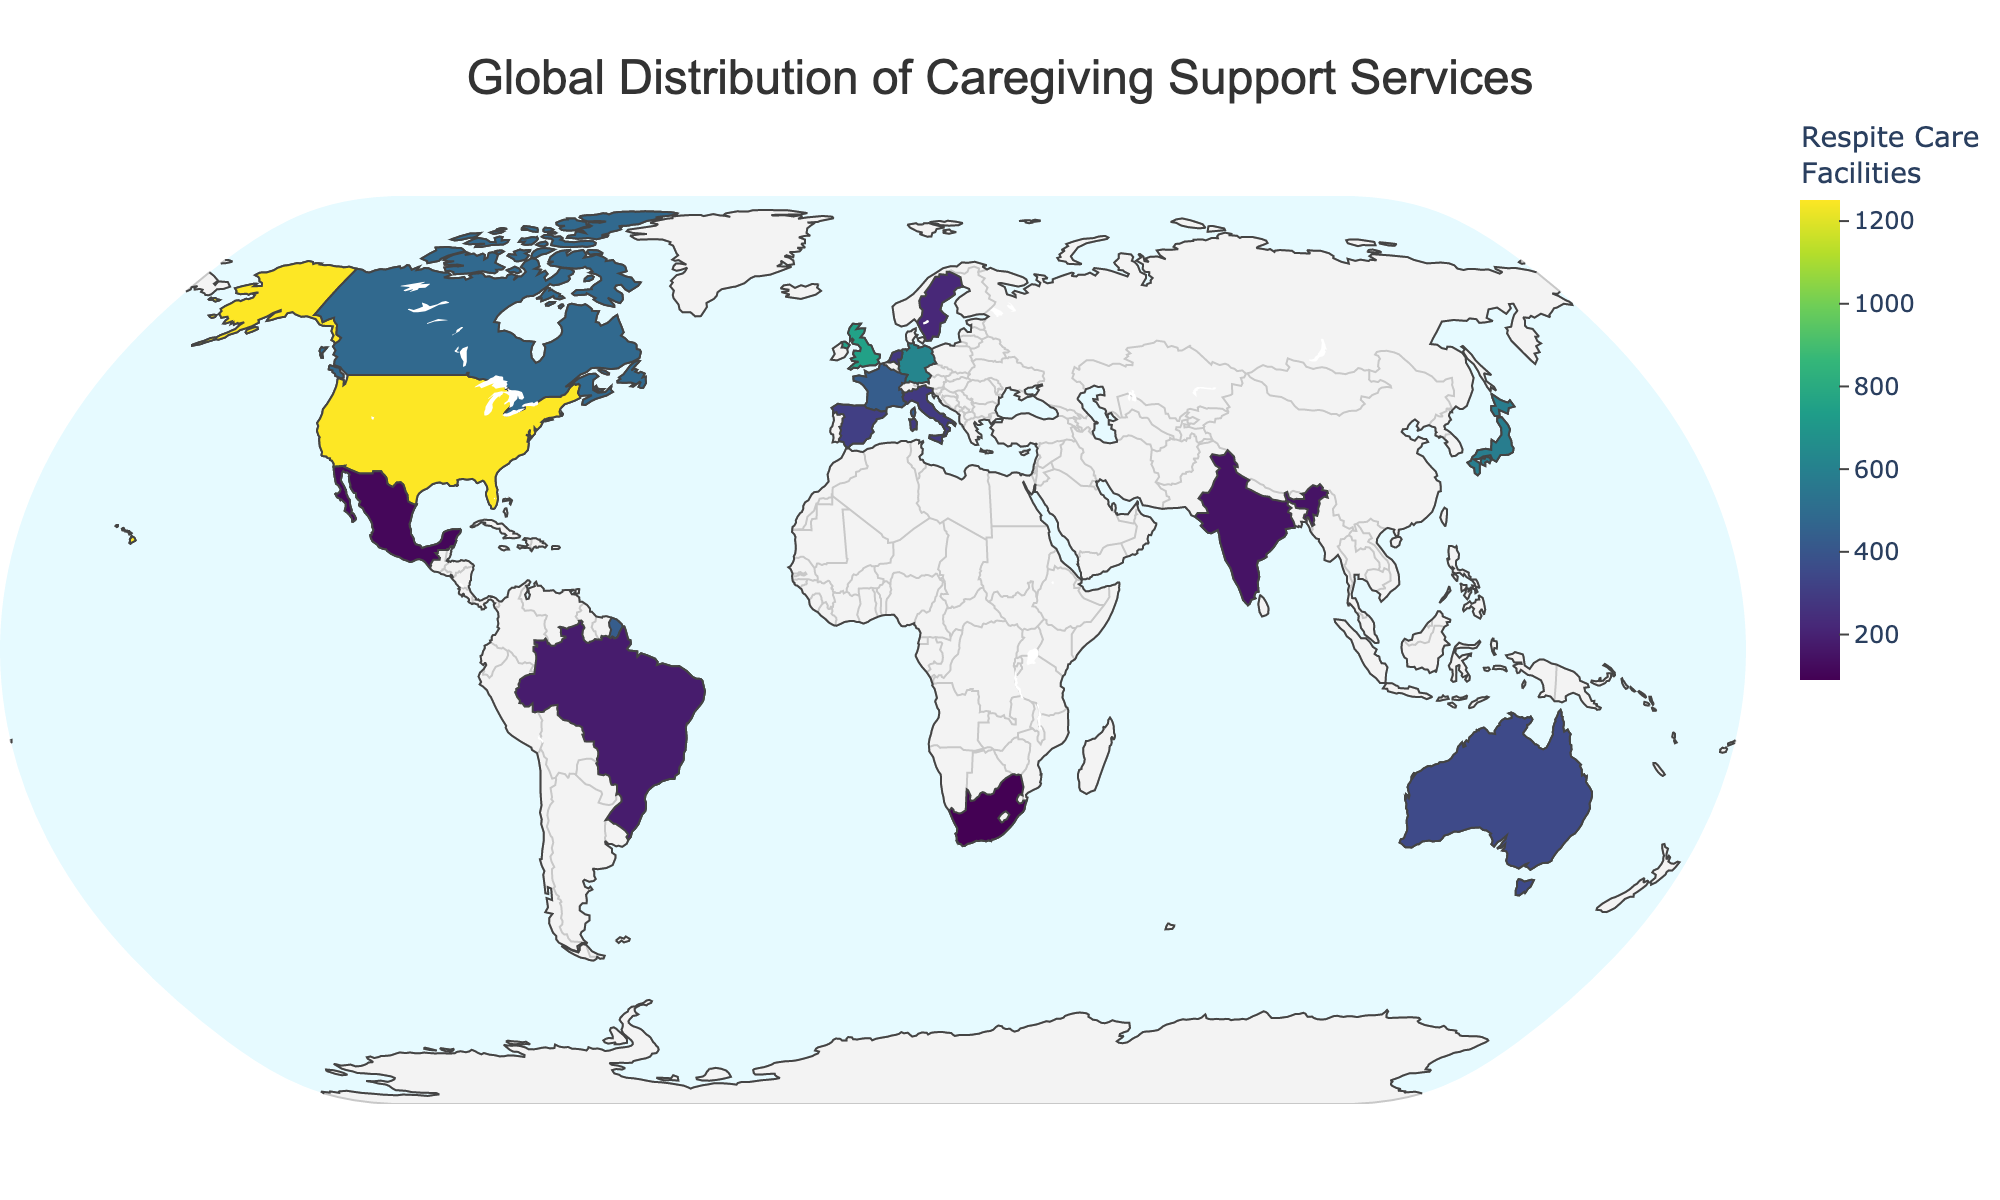What's the country with the highest number of respite care facilities? To find the country with the highest number of respite care facilities, look for the country with the darkest shade on the color scale or check the data for the highest value in the "Respite Care Facilities" column. The United States has the highest number with 1250 facilities.
Answer: United States Which regions have relatively fewer respite care facilities? Identify the countries with lighter shades on the color scale. The countries with relatively fewer facilities are South Africa, Mexico, India, and Brazil.
Answer: South Africa, Mexico, India, Brazil How many respite care facilities do Canada and Australia have combined? Sum the number of respite care facilities for Canada and Australia from the data. Canada has 480, and Australia has 350. Adding them together gives 480 + 350 = 830.
Answer: 830 Which country has more support groups: Germany or the United Kingdom? Compare the number of support groups in Germany and the United Kingdom from the data. Germany has 2000 support groups, and the United Kingdom has 2200. The United Kingdom has more support groups.
Answer: United Kingdom What is the title of the figure? The title of the figure is displayed at the top. It is "Global Distribution of Caregiving Support Services".
Answer: Global Distribution of Caregiving Support Services What color scale is used for portraying the number of respite care facilities? The color scale used to represent the number of respite care facilities is a gradient scale with shades of a single color indicating different ranges. It's the Viridis color scale.
Answer: Viridis What is the ratio of respite care facilities to support groups in the Netherlands? Divide the number of respite care facilities by the number of support groups for the Netherlands. There are 280 respite care facilities and 900 support groups, giving a ratio of 280 / 900 = 0.31 or approximately 31%.
Answer: 0.31 Which countries have a similar number of caregiving support services? To find countries with similar numbers, look for clusters or countries with close values in the respite care facilities, support groups, and training programs. France (430, 1600, 410) and Spain (310, 1100, 280) have relatively similar numbers.
Answer: France, Spain 